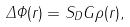Convert formula to latex. <formula><loc_0><loc_0><loc_500><loc_500>\Delta \Phi ( { r } ) = S _ { D } G \rho ( { r } ) ,</formula> 